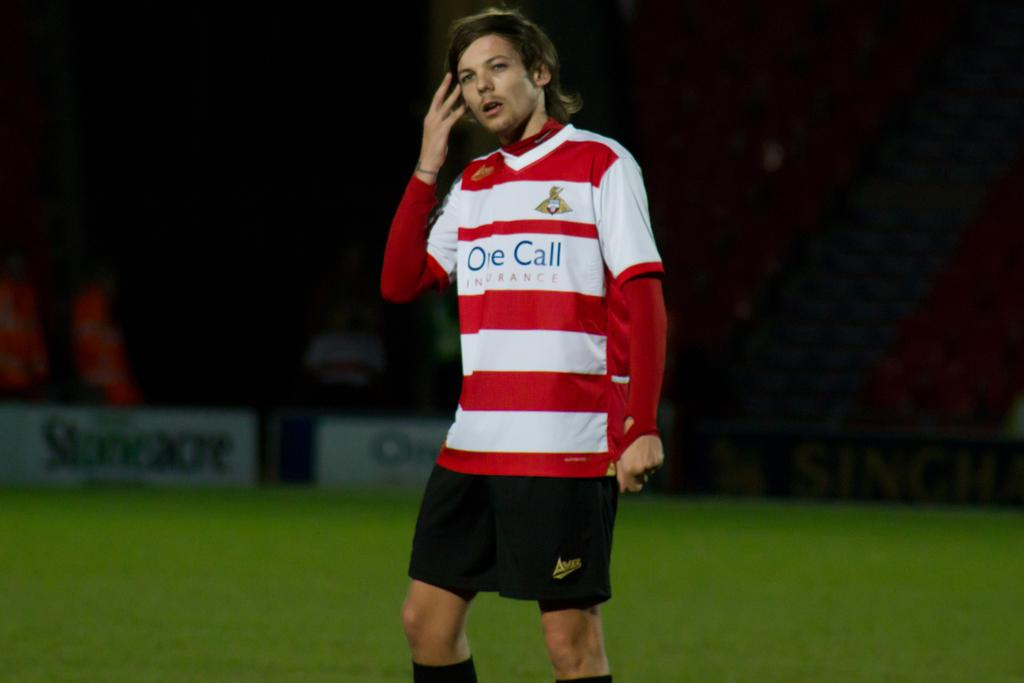Provide a one-sentence caption for the provided image. A soccer player stands on the field with the words one call on his jersey. 